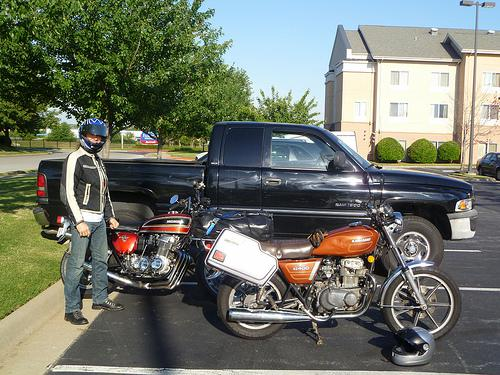Question: what time of day was the photo taken?
Choices:
A. Noon.
B. Morning.
C. Night.
D. Evening.
Answer with the letter. Answer: B Question: what is on the man's head?
Choices:
A. A rag.
B. A turban.
C. A hat.
D. A helmet.
Answer with the letter. Answer: D 